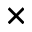Convert formula to latex. <formula><loc_0><loc_0><loc_500><loc_500>\times</formula> 